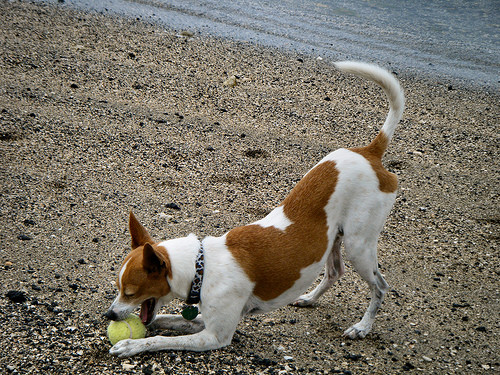<image>
Is there a ball in the dog? Yes. The ball is contained within or inside the dog, showing a containment relationship. Is there a sand in front of the dog? No. The sand is not in front of the dog. The spatial positioning shows a different relationship between these objects. 